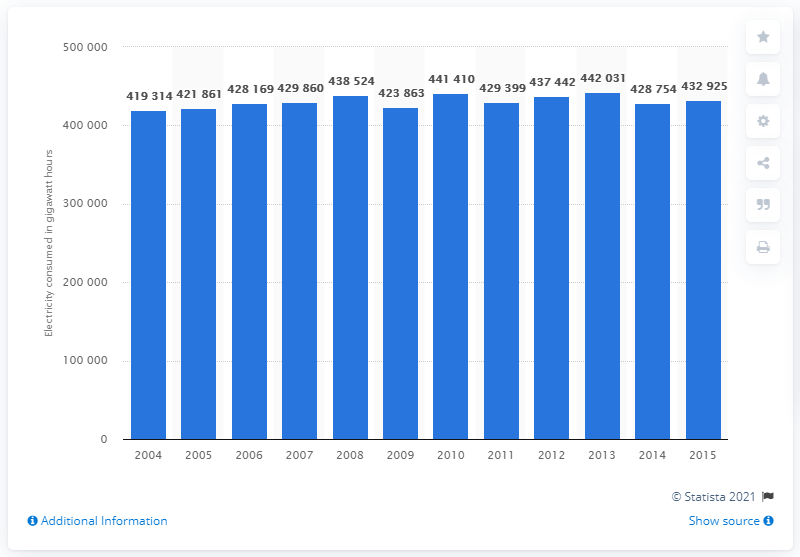Outline some significant characteristics in this image. In 2015, the total amount of electricity consumed in the United States had returned to its level in 2007. 